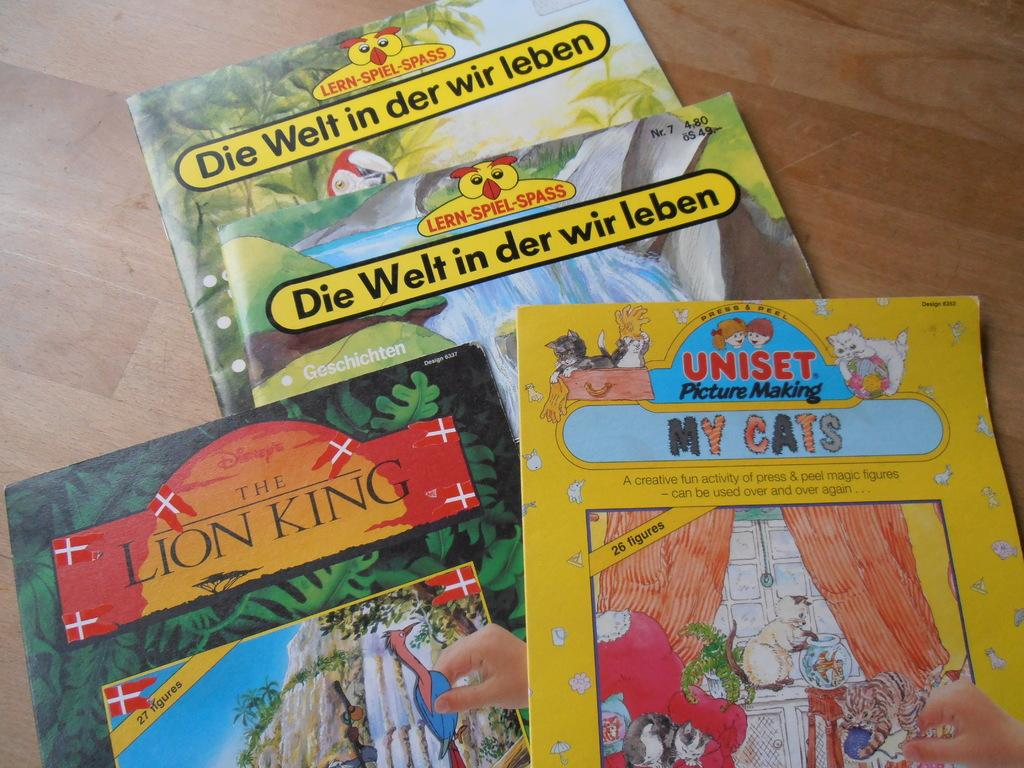Provide a one-sentence caption for the provided image. A collection of children's books, including The Lion King and My Cats. 